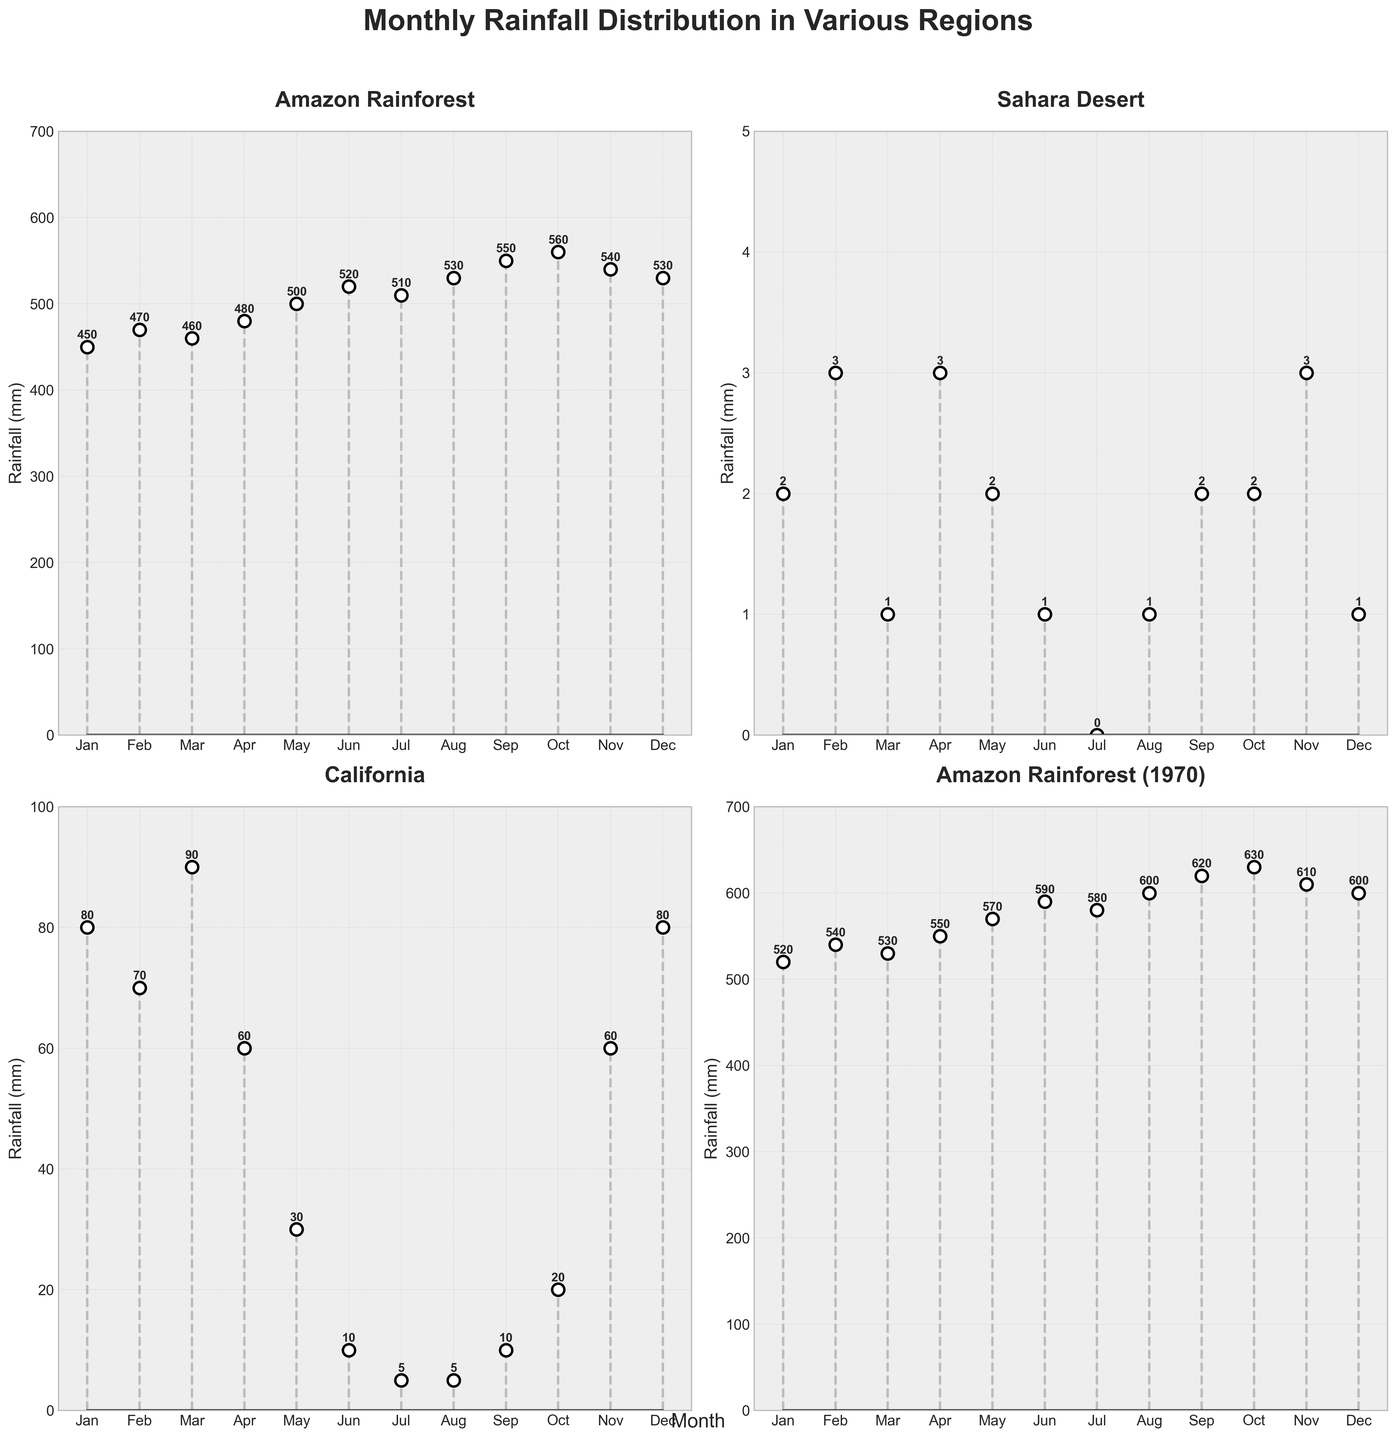What is the title of the subplot collection? The title is displayed at the top and summarizes the content of the figure by mentioning the topic of rainfall distribution and climate change impact.
Answer: Monthly Rainfall Distribution in Various Regions How does the rainfall in the Amazon Rainforest in January 2023 compare to January 1970? The subplot for the Amazon Rainforest indicates the monthly rainfall for both 2023 and 1970. For January, we can see that the rainfall was 450 mm in 2023 and 520 mm in 1970.
Answer: The rainfall is lower in 2023 Which region has the lowest rainfall in July? By comparing the July data across the subplots, the Sahara Desert shows the lowest rainfall with 0 mm marked for July.
Answer: Sahara Desert What is the overall trend in rainfall for California from January to December? Observing the California subplot, the rainfall starts moderately high in January, decreases to almost nil around July and August, then gradually increases back towards December.
Answer: Decreasing then increasing How many regions are depicted in the subplots? The figure has subplots for each unique region mentioned. Counting the titles within the subplots, we find four regions: Amazon Rainforest, Sahara Desert, California, and Amazon Rainforest (1970).
Answer: Four regions In which months does the Sahara Desert receive the highest rainfall? Reviewing the subplot for the Sahara Desert, the months of February, April, and November each have approximately 3 mm of rainfall, the highest for this region.
Answer: February, April, November What is the total annual rainfall in the Amazon Rainforest in 2023? Summing up the monthly values in the subplot for the Amazon Rainforest (2023): 450 + 470 + 460 + 480 + 500 + 520 + 510 + 530 + 550 + 560 + 540 + 530 = 6100 mm.
Answer: 6100 mm What is the difference in rainfall between California and the Amazon Rainforest in June? According to their respective subplots, California has 10 mm of rainfall in June while the Amazon Rainforest has 520 mm. The difference is 520 - 10 = 510 mm.
Answer: 510 mm Which region has the greatest variability in monthly rainfall? By observing the fluctuation within each subplot, the Amazon Rainforest and its 1970 counterpart show a much larger monthly range compared to California and the Sahara Desert, whose variability is quite small.
Answer: Amazon Rainforest Is there any region where rainfall remains constant throughout the year? By checking each subplot, no region shows a perfectly constant rainfall across all months; there are variations in each of the regions depicted.
Answer: No 